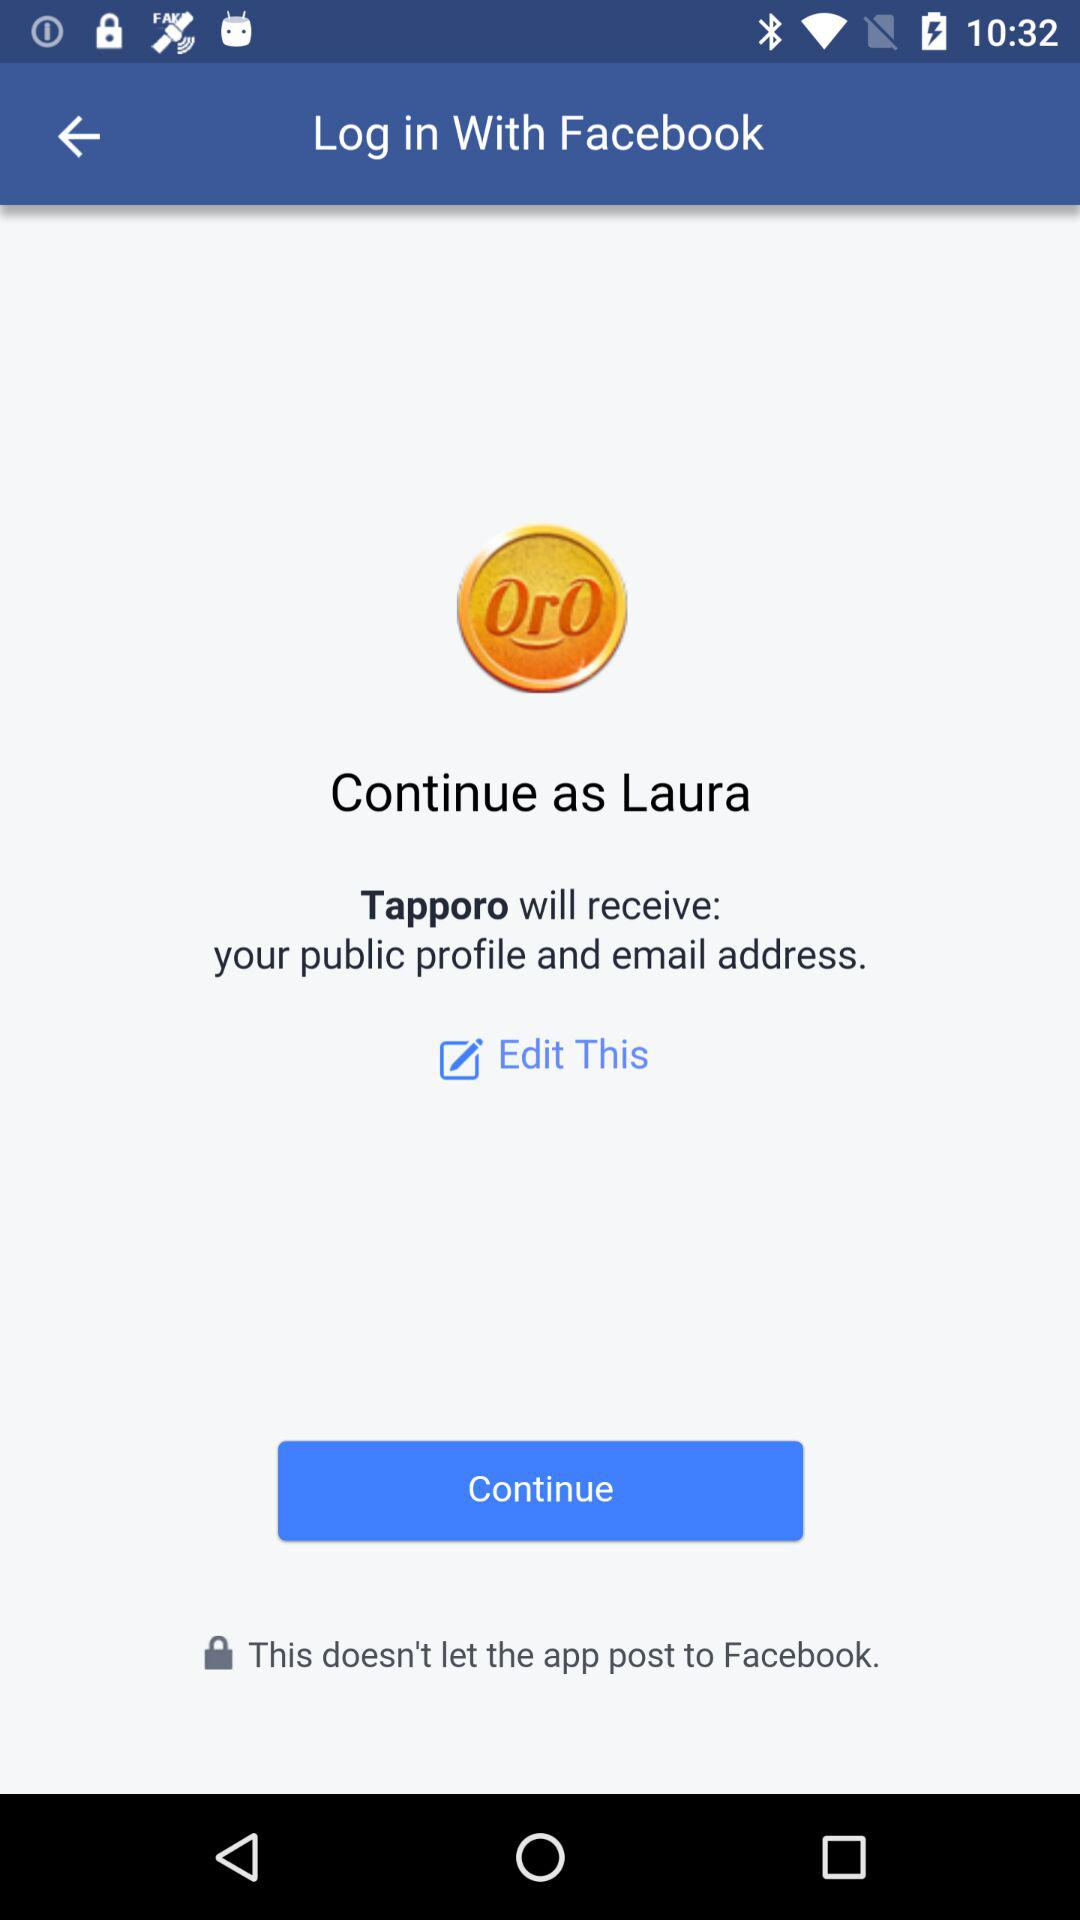What is the name of user? The name of the user is Laura. 